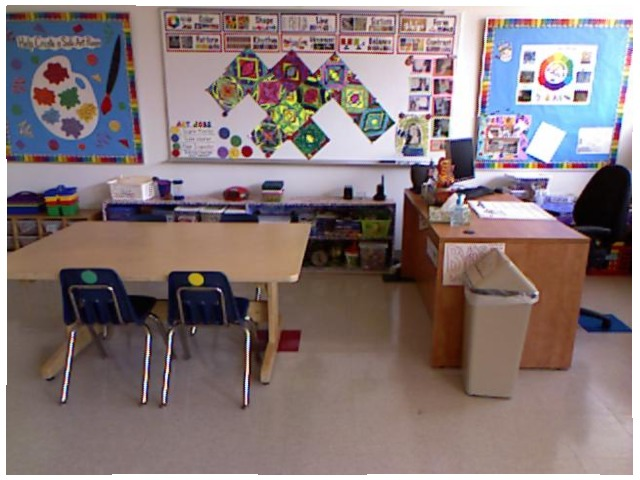<image>
Is there a trashcan in front of the table? No. The trashcan is not in front of the table. The spatial positioning shows a different relationship between these objects. Where is the desk in relation to the garbage can? Is it on the garbage can? No. The desk is not positioned on the garbage can. They may be near each other, but the desk is not supported by or resting on top of the garbage can. Is there a computer to the right of the paint brush? Yes. From this viewpoint, the computer is positioned to the right side relative to the paint brush. Is the chair to the left of the table? No. The chair is not to the left of the table. From this viewpoint, they have a different horizontal relationship. 